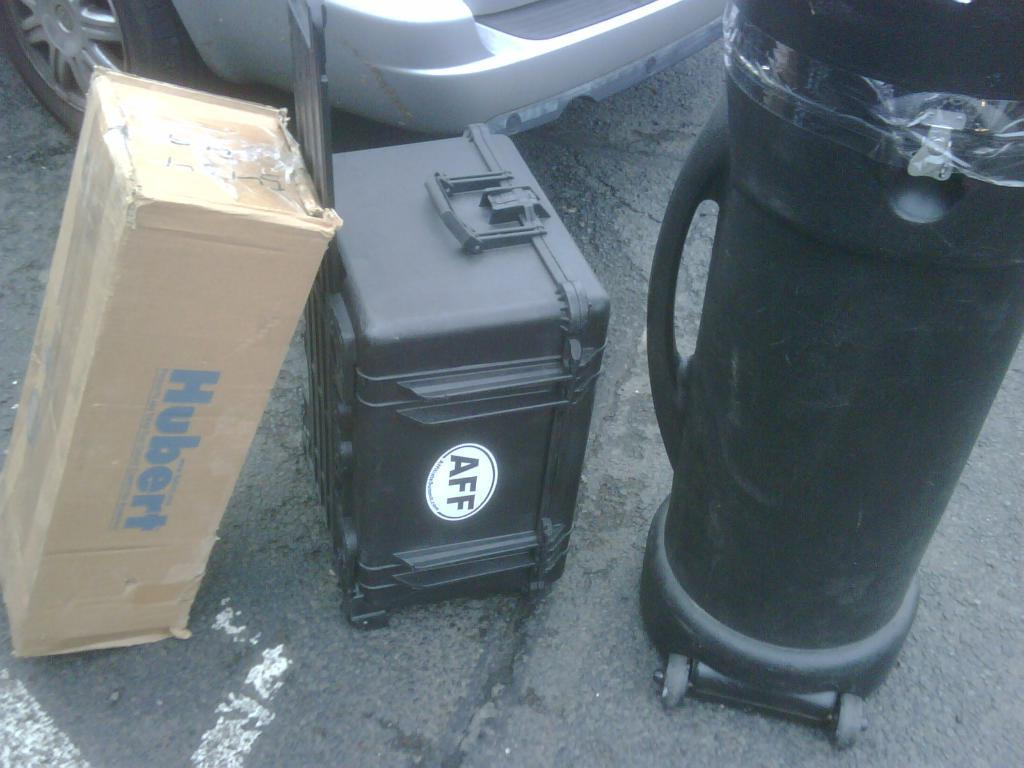Provide a one-sentence caption for the provided image. A box labeled Hubert sits beside a different sized luggage. 